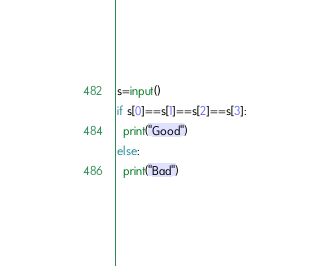Convert code to text. <code><loc_0><loc_0><loc_500><loc_500><_Python_>s=input()
if s[0]==s[1]==s[2]==s[3]:
  print("Good")
else:
  print("Bad")</code> 